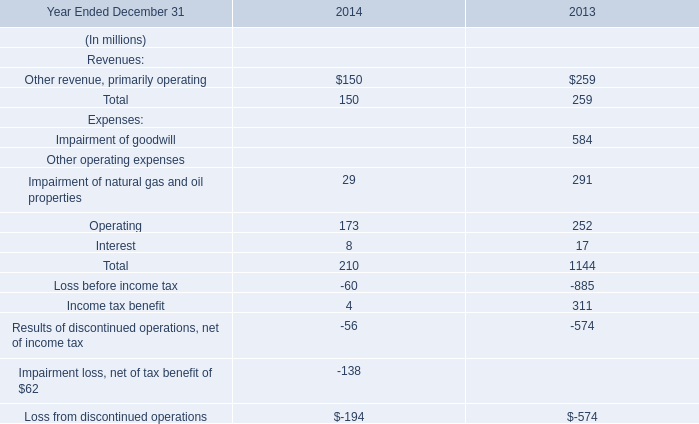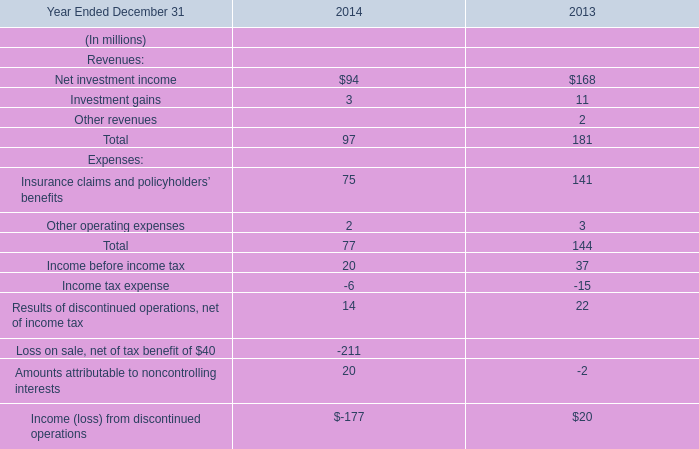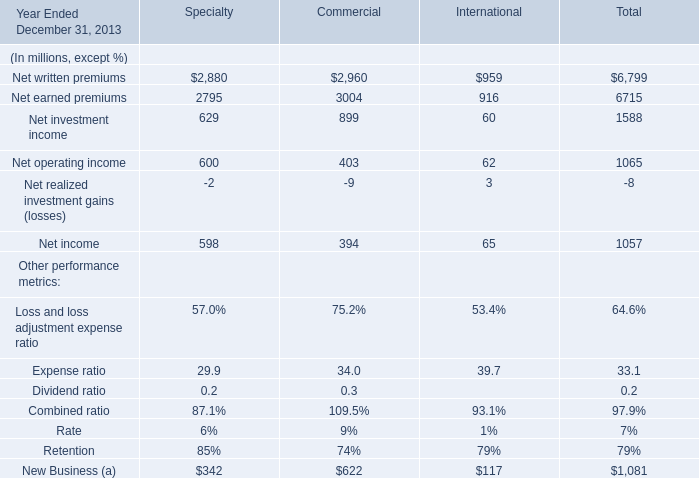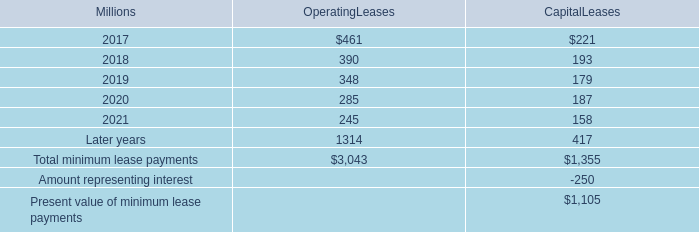what is the highest total amount of Net operating income? (in million) 
Answer: 600. 